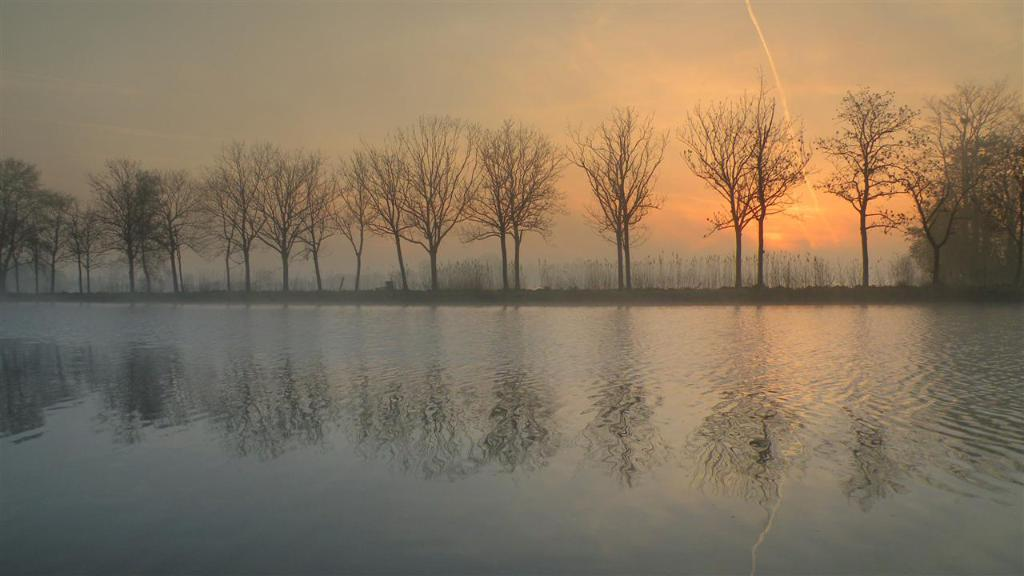What type of vegetation can be seen in the image? There are trees in the image. What natural element is also visible in the image? There is water visible in the image. How would you describe the colors of the sky in the image? The sky has orange, yellow, grey, and black colors. What type of property is being sold in the image? There is no property being sold in the image; it features trees, water, and a sky with various colors. What health advice can be seen in the image? There is no health advice present in the image; it focuses on natural elements and the sky. 